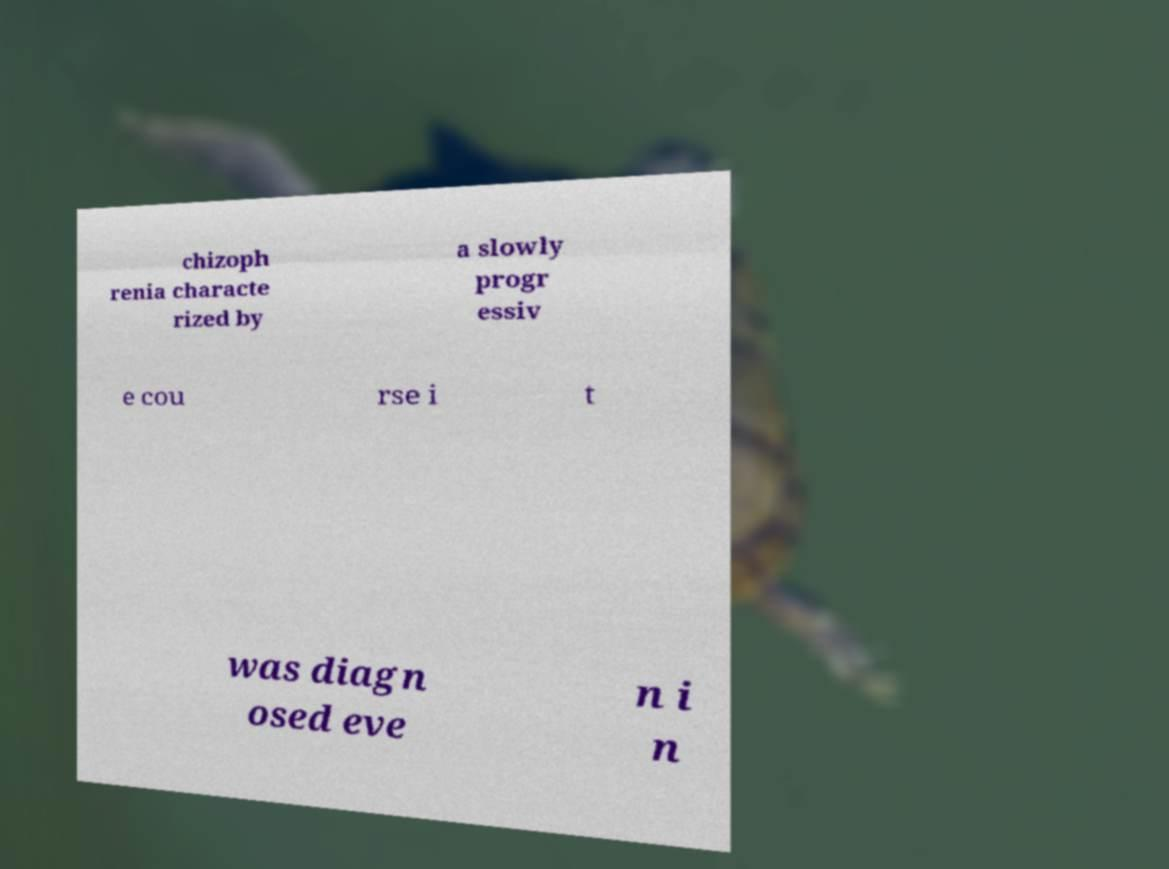Please identify and transcribe the text found in this image. chizoph renia characte rized by a slowly progr essiv e cou rse i t was diagn osed eve n i n 